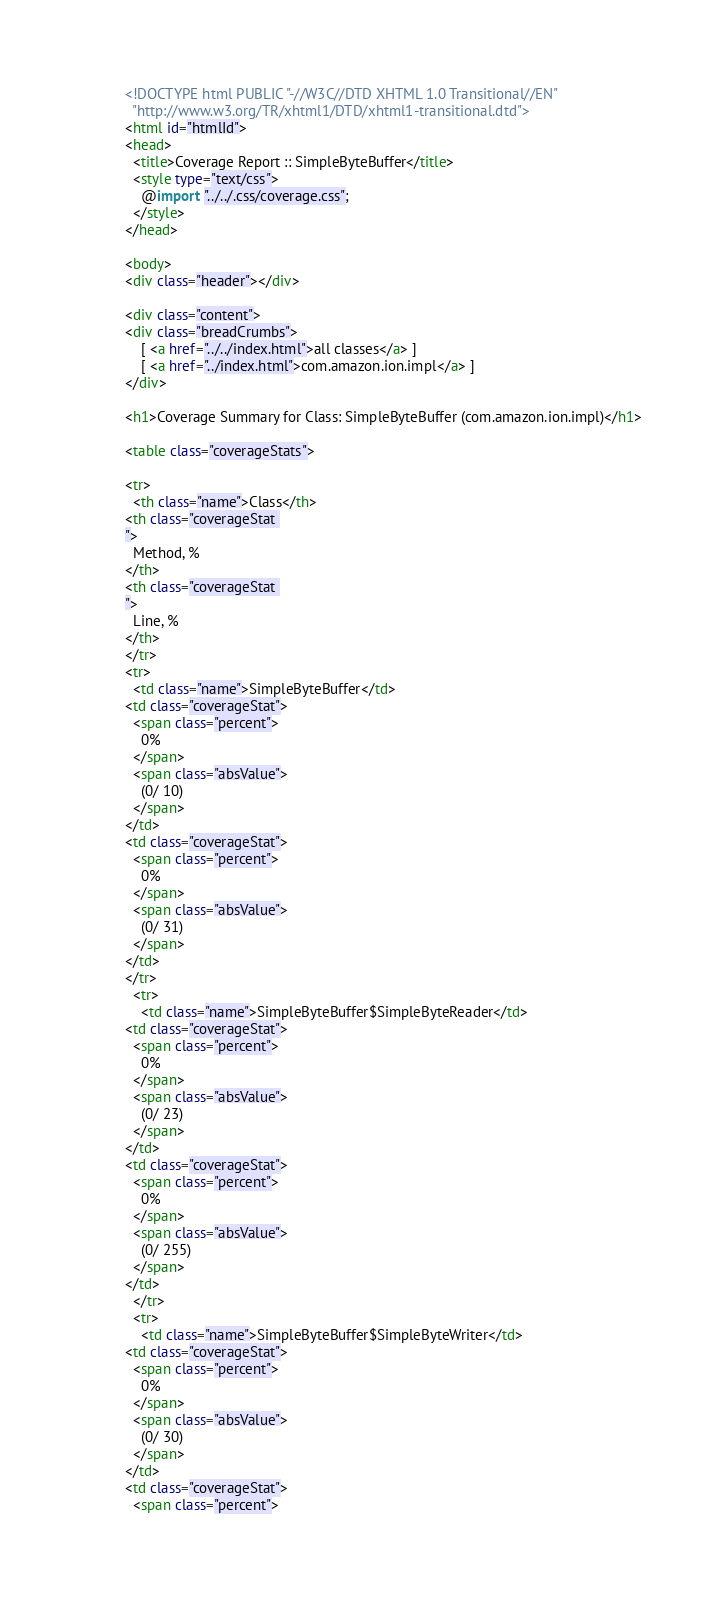Convert code to text. <code><loc_0><loc_0><loc_500><loc_500><_HTML_>


<!DOCTYPE html PUBLIC "-//W3C//DTD XHTML 1.0 Transitional//EN"
  "http://www.w3.org/TR/xhtml1/DTD/xhtml1-transitional.dtd">
<html id="htmlId">
<head>
  <title>Coverage Report :: SimpleByteBuffer</title>
  <style type="text/css">
    @import "../../.css/coverage.css";
  </style>
</head>

<body>
<div class="header"></div>

<div class="content">
<div class="breadCrumbs">
    [ <a href="../../index.html">all classes</a> ]
    [ <a href="../index.html">com.amazon.ion.impl</a> ]
</div>

<h1>Coverage Summary for Class: SimpleByteBuffer (com.amazon.ion.impl)</h1>

<table class="coverageStats">

<tr>
  <th class="name">Class</th>
<th class="coverageStat 
">
  Method, %
</th>
<th class="coverageStat 
">
  Line, %
</th>
</tr>
<tr>
  <td class="name">SimpleByteBuffer</td>
<td class="coverageStat">
  <span class="percent">
    0%
  </span>
  <span class="absValue">
    (0/ 10)
  </span>
</td>
<td class="coverageStat">
  <span class="percent">
    0%
  </span>
  <span class="absValue">
    (0/ 31)
  </span>
</td>
</tr>
  <tr>
    <td class="name">SimpleByteBuffer$SimpleByteReader</td>
<td class="coverageStat">
  <span class="percent">
    0%
  </span>
  <span class="absValue">
    (0/ 23)
  </span>
</td>
<td class="coverageStat">
  <span class="percent">
    0%
  </span>
  <span class="absValue">
    (0/ 255)
  </span>
</td>
  </tr>
  <tr>
    <td class="name">SimpleByteBuffer$SimpleByteWriter</td>
<td class="coverageStat">
  <span class="percent">
    0%
  </span>
  <span class="absValue">
    (0/ 30)
  </span>
</td>
<td class="coverageStat">
  <span class="percent"></code> 